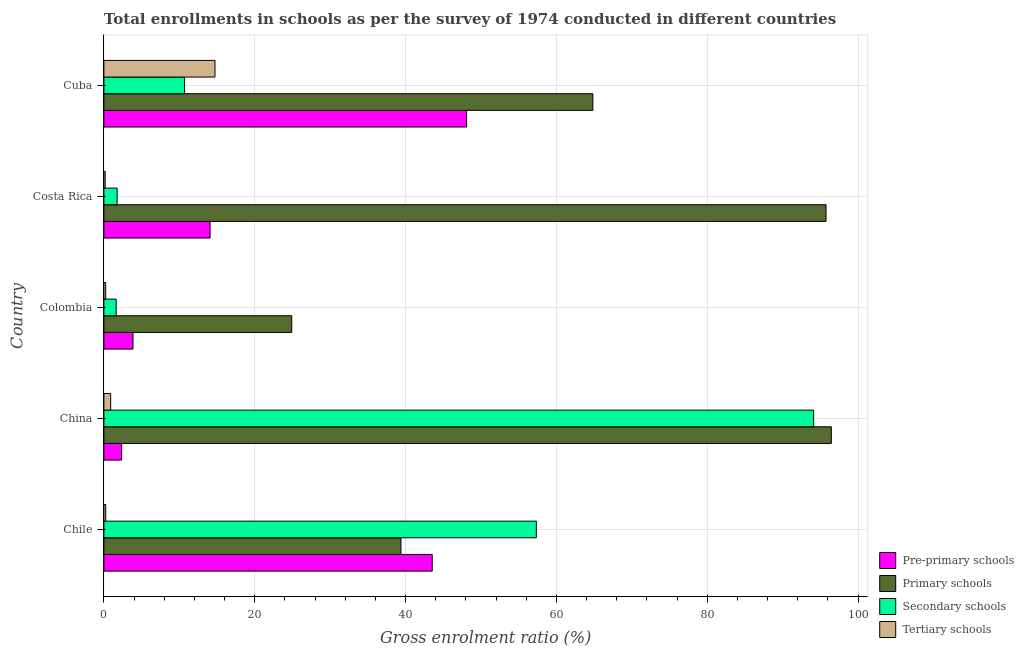Are the number of bars per tick equal to the number of legend labels?
Make the answer very short. Yes. How many bars are there on the 5th tick from the top?
Make the answer very short. 4. What is the gross enrolment ratio in tertiary schools in China?
Your answer should be very brief. 0.9. Across all countries, what is the maximum gross enrolment ratio in primary schools?
Your response must be concise. 96.44. Across all countries, what is the minimum gross enrolment ratio in primary schools?
Your answer should be compact. 24.91. In which country was the gross enrolment ratio in tertiary schools maximum?
Offer a very short reply. Cuba. In which country was the gross enrolment ratio in pre-primary schools minimum?
Give a very brief answer. China. What is the total gross enrolment ratio in primary schools in the graph?
Your response must be concise. 321.3. What is the difference between the gross enrolment ratio in primary schools in China and that in Costa Rica?
Your response must be concise. 0.7. What is the difference between the gross enrolment ratio in primary schools in Costa Rica and the gross enrolment ratio in pre-primary schools in Cuba?
Offer a terse response. 47.65. What is the average gross enrolment ratio in primary schools per country?
Provide a succinct answer. 64.26. What is the difference between the gross enrolment ratio in secondary schools and gross enrolment ratio in primary schools in Cuba?
Offer a terse response. -54.13. In how many countries, is the gross enrolment ratio in tertiary schools greater than 24 %?
Your response must be concise. 0. What is the ratio of the gross enrolment ratio in secondary schools in China to that in Cuba?
Your response must be concise. 8.8. What is the difference between the highest and the second highest gross enrolment ratio in tertiary schools?
Offer a terse response. 13.83. What is the difference between the highest and the lowest gross enrolment ratio in pre-primary schools?
Your answer should be compact. 45.74. Is the sum of the gross enrolment ratio in pre-primary schools in Costa Rica and Cuba greater than the maximum gross enrolment ratio in tertiary schools across all countries?
Provide a short and direct response. Yes. Is it the case that in every country, the sum of the gross enrolment ratio in primary schools and gross enrolment ratio in secondary schools is greater than the sum of gross enrolment ratio in tertiary schools and gross enrolment ratio in pre-primary schools?
Ensure brevity in your answer.  Yes. What does the 4th bar from the top in Colombia represents?
Your response must be concise. Pre-primary schools. What does the 2nd bar from the bottom in Costa Rica represents?
Provide a succinct answer. Primary schools. Is it the case that in every country, the sum of the gross enrolment ratio in pre-primary schools and gross enrolment ratio in primary schools is greater than the gross enrolment ratio in secondary schools?
Your answer should be very brief. Yes. How many bars are there?
Offer a very short reply. 20. Are all the bars in the graph horizontal?
Ensure brevity in your answer.  Yes. How many countries are there in the graph?
Make the answer very short. 5. Are the values on the major ticks of X-axis written in scientific E-notation?
Offer a terse response. No. Does the graph contain any zero values?
Give a very brief answer. No. How many legend labels are there?
Provide a succinct answer. 4. How are the legend labels stacked?
Ensure brevity in your answer.  Vertical. What is the title of the graph?
Your answer should be very brief. Total enrollments in schools as per the survey of 1974 conducted in different countries. What is the label or title of the Y-axis?
Offer a terse response. Country. What is the Gross enrolment ratio (%) of Pre-primary schools in Chile?
Provide a succinct answer. 43.53. What is the Gross enrolment ratio (%) of Primary schools in Chile?
Your answer should be very brief. 39.38. What is the Gross enrolment ratio (%) of Secondary schools in Chile?
Your answer should be compact. 57.33. What is the Gross enrolment ratio (%) of Tertiary schools in Chile?
Keep it short and to the point. 0.24. What is the Gross enrolment ratio (%) in Pre-primary schools in China?
Make the answer very short. 2.35. What is the Gross enrolment ratio (%) in Primary schools in China?
Your answer should be compact. 96.44. What is the Gross enrolment ratio (%) in Secondary schools in China?
Provide a short and direct response. 94.1. What is the Gross enrolment ratio (%) in Tertiary schools in China?
Make the answer very short. 0.9. What is the Gross enrolment ratio (%) in Pre-primary schools in Colombia?
Provide a succinct answer. 3.86. What is the Gross enrolment ratio (%) of Primary schools in Colombia?
Your answer should be compact. 24.91. What is the Gross enrolment ratio (%) in Secondary schools in Colombia?
Your answer should be compact. 1.63. What is the Gross enrolment ratio (%) in Tertiary schools in Colombia?
Give a very brief answer. 0.24. What is the Gross enrolment ratio (%) of Pre-primary schools in Costa Rica?
Offer a very short reply. 14.08. What is the Gross enrolment ratio (%) in Primary schools in Costa Rica?
Offer a very short reply. 95.74. What is the Gross enrolment ratio (%) in Secondary schools in Costa Rica?
Provide a succinct answer. 1.76. What is the Gross enrolment ratio (%) of Tertiary schools in Costa Rica?
Offer a terse response. 0.17. What is the Gross enrolment ratio (%) of Pre-primary schools in Cuba?
Make the answer very short. 48.09. What is the Gross enrolment ratio (%) in Primary schools in Cuba?
Your response must be concise. 64.83. What is the Gross enrolment ratio (%) of Secondary schools in Cuba?
Keep it short and to the point. 10.7. What is the Gross enrolment ratio (%) in Tertiary schools in Cuba?
Offer a very short reply. 14.73. Across all countries, what is the maximum Gross enrolment ratio (%) of Pre-primary schools?
Your answer should be compact. 48.09. Across all countries, what is the maximum Gross enrolment ratio (%) in Primary schools?
Keep it short and to the point. 96.44. Across all countries, what is the maximum Gross enrolment ratio (%) of Secondary schools?
Give a very brief answer. 94.1. Across all countries, what is the maximum Gross enrolment ratio (%) of Tertiary schools?
Give a very brief answer. 14.73. Across all countries, what is the minimum Gross enrolment ratio (%) of Pre-primary schools?
Your response must be concise. 2.35. Across all countries, what is the minimum Gross enrolment ratio (%) in Primary schools?
Make the answer very short. 24.91. Across all countries, what is the minimum Gross enrolment ratio (%) in Secondary schools?
Make the answer very short. 1.63. Across all countries, what is the minimum Gross enrolment ratio (%) in Tertiary schools?
Provide a short and direct response. 0.17. What is the total Gross enrolment ratio (%) in Pre-primary schools in the graph?
Make the answer very short. 111.91. What is the total Gross enrolment ratio (%) in Primary schools in the graph?
Offer a very short reply. 321.3. What is the total Gross enrolment ratio (%) of Secondary schools in the graph?
Ensure brevity in your answer.  165.52. What is the total Gross enrolment ratio (%) of Tertiary schools in the graph?
Make the answer very short. 16.28. What is the difference between the Gross enrolment ratio (%) of Pre-primary schools in Chile and that in China?
Provide a succinct answer. 41.18. What is the difference between the Gross enrolment ratio (%) in Primary schools in Chile and that in China?
Provide a short and direct response. -57.06. What is the difference between the Gross enrolment ratio (%) in Secondary schools in Chile and that in China?
Ensure brevity in your answer.  -36.77. What is the difference between the Gross enrolment ratio (%) in Tertiary schools in Chile and that in China?
Make the answer very short. -0.66. What is the difference between the Gross enrolment ratio (%) of Pre-primary schools in Chile and that in Colombia?
Your response must be concise. 39.67. What is the difference between the Gross enrolment ratio (%) in Primary schools in Chile and that in Colombia?
Make the answer very short. 14.47. What is the difference between the Gross enrolment ratio (%) in Secondary schools in Chile and that in Colombia?
Provide a succinct answer. 55.71. What is the difference between the Gross enrolment ratio (%) of Tertiary schools in Chile and that in Colombia?
Keep it short and to the point. 0. What is the difference between the Gross enrolment ratio (%) of Pre-primary schools in Chile and that in Costa Rica?
Ensure brevity in your answer.  29.45. What is the difference between the Gross enrolment ratio (%) of Primary schools in Chile and that in Costa Rica?
Make the answer very short. -56.36. What is the difference between the Gross enrolment ratio (%) in Secondary schools in Chile and that in Costa Rica?
Offer a terse response. 55.58. What is the difference between the Gross enrolment ratio (%) of Tertiary schools in Chile and that in Costa Rica?
Keep it short and to the point. 0.07. What is the difference between the Gross enrolment ratio (%) of Pre-primary schools in Chile and that in Cuba?
Offer a very short reply. -4.56. What is the difference between the Gross enrolment ratio (%) in Primary schools in Chile and that in Cuba?
Ensure brevity in your answer.  -25.44. What is the difference between the Gross enrolment ratio (%) of Secondary schools in Chile and that in Cuba?
Provide a succinct answer. 46.64. What is the difference between the Gross enrolment ratio (%) of Tertiary schools in Chile and that in Cuba?
Your answer should be very brief. -14.48. What is the difference between the Gross enrolment ratio (%) of Pre-primary schools in China and that in Colombia?
Keep it short and to the point. -1.51. What is the difference between the Gross enrolment ratio (%) of Primary schools in China and that in Colombia?
Ensure brevity in your answer.  71.53. What is the difference between the Gross enrolment ratio (%) of Secondary schools in China and that in Colombia?
Offer a terse response. 92.47. What is the difference between the Gross enrolment ratio (%) in Tertiary schools in China and that in Colombia?
Make the answer very short. 0.66. What is the difference between the Gross enrolment ratio (%) in Pre-primary schools in China and that in Costa Rica?
Make the answer very short. -11.73. What is the difference between the Gross enrolment ratio (%) in Primary schools in China and that in Costa Rica?
Make the answer very short. 0.7. What is the difference between the Gross enrolment ratio (%) of Secondary schools in China and that in Costa Rica?
Your answer should be very brief. 92.34. What is the difference between the Gross enrolment ratio (%) of Tertiary schools in China and that in Costa Rica?
Your answer should be compact. 0.72. What is the difference between the Gross enrolment ratio (%) in Pre-primary schools in China and that in Cuba?
Keep it short and to the point. -45.74. What is the difference between the Gross enrolment ratio (%) in Primary schools in China and that in Cuba?
Your answer should be very brief. 31.62. What is the difference between the Gross enrolment ratio (%) in Secondary schools in China and that in Cuba?
Provide a short and direct response. 83.4. What is the difference between the Gross enrolment ratio (%) in Tertiary schools in China and that in Cuba?
Your response must be concise. -13.83. What is the difference between the Gross enrolment ratio (%) in Pre-primary schools in Colombia and that in Costa Rica?
Your answer should be very brief. -10.22. What is the difference between the Gross enrolment ratio (%) of Primary schools in Colombia and that in Costa Rica?
Provide a succinct answer. -70.84. What is the difference between the Gross enrolment ratio (%) in Secondary schools in Colombia and that in Costa Rica?
Provide a short and direct response. -0.13. What is the difference between the Gross enrolment ratio (%) in Tertiary schools in Colombia and that in Costa Rica?
Ensure brevity in your answer.  0.06. What is the difference between the Gross enrolment ratio (%) in Pre-primary schools in Colombia and that in Cuba?
Ensure brevity in your answer.  -44.23. What is the difference between the Gross enrolment ratio (%) in Primary schools in Colombia and that in Cuba?
Keep it short and to the point. -39.92. What is the difference between the Gross enrolment ratio (%) in Secondary schools in Colombia and that in Cuba?
Your response must be concise. -9.07. What is the difference between the Gross enrolment ratio (%) in Tertiary schools in Colombia and that in Cuba?
Offer a very short reply. -14.49. What is the difference between the Gross enrolment ratio (%) of Pre-primary schools in Costa Rica and that in Cuba?
Your answer should be very brief. -34.01. What is the difference between the Gross enrolment ratio (%) of Primary schools in Costa Rica and that in Cuba?
Make the answer very short. 30.92. What is the difference between the Gross enrolment ratio (%) in Secondary schools in Costa Rica and that in Cuba?
Provide a short and direct response. -8.94. What is the difference between the Gross enrolment ratio (%) in Tertiary schools in Costa Rica and that in Cuba?
Your answer should be compact. -14.55. What is the difference between the Gross enrolment ratio (%) of Pre-primary schools in Chile and the Gross enrolment ratio (%) of Primary schools in China?
Your response must be concise. -52.91. What is the difference between the Gross enrolment ratio (%) of Pre-primary schools in Chile and the Gross enrolment ratio (%) of Secondary schools in China?
Provide a succinct answer. -50.57. What is the difference between the Gross enrolment ratio (%) of Pre-primary schools in Chile and the Gross enrolment ratio (%) of Tertiary schools in China?
Offer a terse response. 42.63. What is the difference between the Gross enrolment ratio (%) of Primary schools in Chile and the Gross enrolment ratio (%) of Secondary schools in China?
Offer a very short reply. -54.72. What is the difference between the Gross enrolment ratio (%) in Primary schools in Chile and the Gross enrolment ratio (%) in Tertiary schools in China?
Ensure brevity in your answer.  38.48. What is the difference between the Gross enrolment ratio (%) in Secondary schools in Chile and the Gross enrolment ratio (%) in Tertiary schools in China?
Offer a terse response. 56.44. What is the difference between the Gross enrolment ratio (%) in Pre-primary schools in Chile and the Gross enrolment ratio (%) in Primary schools in Colombia?
Make the answer very short. 18.62. What is the difference between the Gross enrolment ratio (%) in Pre-primary schools in Chile and the Gross enrolment ratio (%) in Secondary schools in Colombia?
Your answer should be compact. 41.9. What is the difference between the Gross enrolment ratio (%) of Pre-primary schools in Chile and the Gross enrolment ratio (%) of Tertiary schools in Colombia?
Provide a succinct answer. 43.29. What is the difference between the Gross enrolment ratio (%) of Primary schools in Chile and the Gross enrolment ratio (%) of Secondary schools in Colombia?
Offer a very short reply. 37.75. What is the difference between the Gross enrolment ratio (%) in Primary schools in Chile and the Gross enrolment ratio (%) in Tertiary schools in Colombia?
Make the answer very short. 39.14. What is the difference between the Gross enrolment ratio (%) in Secondary schools in Chile and the Gross enrolment ratio (%) in Tertiary schools in Colombia?
Provide a succinct answer. 57.09. What is the difference between the Gross enrolment ratio (%) in Pre-primary schools in Chile and the Gross enrolment ratio (%) in Primary schools in Costa Rica?
Your answer should be compact. -52.21. What is the difference between the Gross enrolment ratio (%) of Pre-primary schools in Chile and the Gross enrolment ratio (%) of Secondary schools in Costa Rica?
Provide a succinct answer. 41.78. What is the difference between the Gross enrolment ratio (%) of Pre-primary schools in Chile and the Gross enrolment ratio (%) of Tertiary schools in Costa Rica?
Ensure brevity in your answer.  43.36. What is the difference between the Gross enrolment ratio (%) in Primary schools in Chile and the Gross enrolment ratio (%) in Secondary schools in Costa Rica?
Your answer should be compact. 37.63. What is the difference between the Gross enrolment ratio (%) of Primary schools in Chile and the Gross enrolment ratio (%) of Tertiary schools in Costa Rica?
Your response must be concise. 39.21. What is the difference between the Gross enrolment ratio (%) in Secondary schools in Chile and the Gross enrolment ratio (%) in Tertiary schools in Costa Rica?
Offer a terse response. 57.16. What is the difference between the Gross enrolment ratio (%) in Pre-primary schools in Chile and the Gross enrolment ratio (%) in Primary schools in Cuba?
Give a very brief answer. -21.3. What is the difference between the Gross enrolment ratio (%) in Pre-primary schools in Chile and the Gross enrolment ratio (%) in Secondary schools in Cuba?
Your answer should be compact. 32.83. What is the difference between the Gross enrolment ratio (%) in Pre-primary schools in Chile and the Gross enrolment ratio (%) in Tertiary schools in Cuba?
Make the answer very short. 28.8. What is the difference between the Gross enrolment ratio (%) in Primary schools in Chile and the Gross enrolment ratio (%) in Secondary schools in Cuba?
Your answer should be very brief. 28.68. What is the difference between the Gross enrolment ratio (%) in Primary schools in Chile and the Gross enrolment ratio (%) in Tertiary schools in Cuba?
Provide a short and direct response. 24.65. What is the difference between the Gross enrolment ratio (%) in Secondary schools in Chile and the Gross enrolment ratio (%) in Tertiary schools in Cuba?
Your answer should be compact. 42.61. What is the difference between the Gross enrolment ratio (%) in Pre-primary schools in China and the Gross enrolment ratio (%) in Primary schools in Colombia?
Give a very brief answer. -22.56. What is the difference between the Gross enrolment ratio (%) of Pre-primary schools in China and the Gross enrolment ratio (%) of Secondary schools in Colombia?
Offer a very short reply. 0.72. What is the difference between the Gross enrolment ratio (%) in Pre-primary schools in China and the Gross enrolment ratio (%) in Tertiary schools in Colombia?
Offer a very short reply. 2.11. What is the difference between the Gross enrolment ratio (%) of Primary schools in China and the Gross enrolment ratio (%) of Secondary schools in Colombia?
Your answer should be compact. 94.81. What is the difference between the Gross enrolment ratio (%) of Primary schools in China and the Gross enrolment ratio (%) of Tertiary schools in Colombia?
Your response must be concise. 96.2. What is the difference between the Gross enrolment ratio (%) in Secondary schools in China and the Gross enrolment ratio (%) in Tertiary schools in Colombia?
Make the answer very short. 93.86. What is the difference between the Gross enrolment ratio (%) in Pre-primary schools in China and the Gross enrolment ratio (%) in Primary schools in Costa Rica?
Provide a succinct answer. -93.39. What is the difference between the Gross enrolment ratio (%) in Pre-primary schools in China and the Gross enrolment ratio (%) in Secondary schools in Costa Rica?
Offer a very short reply. 0.6. What is the difference between the Gross enrolment ratio (%) in Pre-primary schools in China and the Gross enrolment ratio (%) in Tertiary schools in Costa Rica?
Your answer should be very brief. 2.18. What is the difference between the Gross enrolment ratio (%) in Primary schools in China and the Gross enrolment ratio (%) in Secondary schools in Costa Rica?
Your answer should be compact. 94.69. What is the difference between the Gross enrolment ratio (%) of Primary schools in China and the Gross enrolment ratio (%) of Tertiary schools in Costa Rica?
Your answer should be very brief. 96.27. What is the difference between the Gross enrolment ratio (%) in Secondary schools in China and the Gross enrolment ratio (%) in Tertiary schools in Costa Rica?
Offer a very short reply. 93.92. What is the difference between the Gross enrolment ratio (%) of Pre-primary schools in China and the Gross enrolment ratio (%) of Primary schools in Cuba?
Offer a very short reply. -62.48. What is the difference between the Gross enrolment ratio (%) of Pre-primary schools in China and the Gross enrolment ratio (%) of Secondary schools in Cuba?
Give a very brief answer. -8.35. What is the difference between the Gross enrolment ratio (%) in Pre-primary schools in China and the Gross enrolment ratio (%) in Tertiary schools in Cuba?
Keep it short and to the point. -12.38. What is the difference between the Gross enrolment ratio (%) of Primary schools in China and the Gross enrolment ratio (%) of Secondary schools in Cuba?
Offer a terse response. 85.75. What is the difference between the Gross enrolment ratio (%) of Primary schools in China and the Gross enrolment ratio (%) of Tertiary schools in Cuba?
Provide a succinct answer. 81.72. What is the difference between the Gross enrolment ratio (%) in Secondary schools in China and the Gross enrolment ratio (%) in Tertiary schools in Cuba?
Your answer should be compact. 79.37. What is the difference between the Gross enrolment ratio (%) in Pre-primary schools in Colombia and the Gross enrolment ratio (%) in Primary schools in Costa Rica?
Provide a short and direct response. -91.89. What is the difference between the Gross enrolment ratio (%) in Pre-primary schools in Colombia and the Gross enrolment ratio (%) in Secondary schools in Costa Rica?
Ensure brevity in your answer.  2.1. What is the difference between the Gross enrolment ratio (%) of Pre-primary schools in Colombia and the Gross enrolment ratio (%) of Tertiary schools in Costa Rica?
Your answer should be compact. 3.68. What is the difference between the Gross enrolment ratio (%) of Primary schools in Colombia and the Gross enrolment ratio (%) of Secondary schools in Costa Rica?
Ensure brevity in your answer.  23.15. What is the difference between the Gross enrolment ratio (%) of Primary schools in Colombia and the Gross enrolment ratio (%) of Tertiary schools in Costa Rica?
Provide a succinct answer. 24.73. What is the difference between the Gross enrolment ratio (%) of Secondary schools in Colombia and the Gross enrolment ratio (%) of Tertiary schools in Costa Rica?
Give a very brief answer. 1.45. What is the difference between the Gross enrolment ratio (%) in Pre-primary schools in Colombia and the Gross enrolment ratio (%) in Primary schools in Cuba?
Ensure brevity in your answer.  -60.97. What is the difference between the Gross enrolment ratio (%) of Pre-primary schools in Colombia and the Gross enrolment ratio (%) of Secondary schools in Cuba?
Keep it short and to the point. -6.84. What is the difference between the Gross enrolment ratio (%) of Pre-primary schools in Colombia and the Gross enrolment ratio (%) of Tertiary schools in Cuba?
Offer a very short reply. -10.87. What is the difference between the Gross enrolment ratio (%) of Primary schools in Colombia and the Gross enrolment ratio (%) of Secondary schools in Cuba?
Offer a terse response. 14.21. What is the difference between the Gross enrolment ratio (%) of Primary schools in Colombia and the Gross enrolment ratio (%) of Tertiary schools in Cuba?
Offer a very short reply. 10.18. What is the difference between the Gross enrolment ratio (%) in Secondary schools in Colombia and the Gross enrolment ratio (%) in Tertiary schools in Cuba?
Offer a terse response. -13.1. What is the difference between the Gross enrolment ratio (%) in Pre-primary schools in Costa Rica and the Gross enrolment ratio (%) in Primary schools in Cuba?
Your response must be concise. -50.75. What is the difference between the Gross enrolment ratio (%) of Pre-primary schools in Costa Rica and the Gross enrolment ratio (%) of Secondary schools in Cuba?
Provide a succinct answer. 3.38. What is the difference between the Gross enrolment ratio (%) in Pre-primary schools in Costa Rica and the Gross enrolment ratio (%) in Tertiary schools in Cuba?
Offer a very short reply. -0.65. What is the difference between the Gross enrolment ratio (%) in Primary schools in Costa Rica and the Gross enrolment ratio (%) in Secondary schools in Cuba?
Ensure brevity in your answer.  85.05. What is the difference between the Gross enrolment ratio (%) of Primary schools in Costa Rica and the Gross enrolment ratio (%) of Tertiary schools in Cuba?
Your response must be concise. 81.02. What is the difference between the Gross enrolment ratio (%) in Secondary schools in Costa Rica and the Gross enrolment ratio (%) in Tertiary schools in Cuba?
Offer a very short reply. -12.97. What is the average Gross enrolment ratio (%) in Pre-primary schools per country?
Your response must be concise. 22.38. What is the average Gross enrolment ratio (%) of Primary schools per country?
Provide a short and direct response. 64.26. What is the average Gross enrolment ratio (%) of Secondary schools per country?
Give a very brief answer. 33.1. What is the average Gross enrolment ratio (%) of Tertiary schools per country?
Provide a succinct answer. 3.26. What is the difference between the Gross enrolment ratio (%) of Pre-primary schools and Gross enrolment ratio (%) of Primary schools in Chile?
Give a very brief answer. 4.15. What is the difference between the Gross enrolment ratio (%) in Pre-primary schools and Gross enrolment ratio (%) in Secondary schools in Chile?
Ensure brevity in your answer.  -13.8. What is the difference between the Gross enrolment ratio (%) in Pre-primary schools and Gross enrolment ratio (%) in Tertiary schools in Chile?
Give a very brief answer. 43.29. What is the difference between the Gross enrolment ratio (%) in Primary schools and Gross enrolment ratio (%) in Secondary schools in Chile?
Give a very brief answer. -17.95. What is the difference between the Gross enrolment ratio (%) of Primary schools and Gross enrolment ratio (%) of Tertiary schools in Chile?
Your answer should be compact. 39.14. What is the difference between the Gross enrolment ratio (%) in Secondary schools and Gross enrolment ratio (%) in Tertiary schools in Chile?
Your response must be concise. 57.09. What is the difference between the Gross enrolment ratio (%) in Pre-primary schools and Gross enrolment ratio (%) in Primary schools in China?
Offer a very short reply. -94.09. What is the difference between the Gross enrolment ratio (%) in Pre-primary schools and Gross enrolment ratio (%) in Secondary schools in China?
Your answer should be very brief. -91.75. What is the difference between the Gross enrolment ratio (%) of Pre-primary schools and Gross enrolment ratio (%) of Tertiary schools in China?
Make the answer very short. 1.45. What is the difference between the Gross enrolment ratio (%) of Primary schools and Gross enrolment ratio (%) of Secondary schools in China?
Your answer should be very brief. 2.34. What is the difference between the Gross enrolment ratio (%) in Primary schools and Gross enrolment ratio (%) in Tertiary schools in China?
Your answer should be compact. 95.54. What is the difference between the Gross enrolment ratio (%) in Secondary schools and Gross enrolment ratio (%) in Tertiary schools in China?
Give a very brief answer. 93.2. What is the difference between the Gross enrolment ratio (%) in Pre-primary schools and Gross enrolment ratio (%) in Primary schools in Colombia?
Ensure brevity in your answer.  -21.05. What is the difference between the Gross enrolment ratio (%) in Pre-primary schools and Gross enrolment ratio (%) in Secondary schools in Colombia?
Give a very brief answer. 2.23. What is the difference between the Gross enrolment ratio (%) in Pre-primary schools and Gross enrolment ratio (%) in Tertiary schools in Colombia?
Keep it short and to the point. 3.62. What is the difference between the Gross enrolment ratio (%) of Primary schools and Gross enrolment ratio (%) of Secondary schools in Colombia?
Provide a succinct answer. 23.28. What is the difference between the Gross enrolment ratio (%) in Primary schools and Gross enrolment ratio (%) in Tertiary schools in Colombia?
Make the answer very short. 24.67. What is the difference between the Gross enrolment ratio (%) in Secondary schools and Gross enrolment ratio (%) in Tertiary schools in Colombia?
Give a very brief answer. 1.39. What is the difference between the Gross enrolment ratio (%) in Pre-primary schools and Gross enrolment ratio (%) in Primary schools in Costa Rica?
Offer a terse response. -81.67. What is the difference between the Gross enrolment ratio (%) of Pre-primary schools and Gross enrolment ratio (%) of Secondary schools in Costa Rica?
Make the answer very short. 12.32. What is the difference between the Gross enrolment ratio (%) of Pre-primary schools and Gross enrolment ratio (%) of Tertiary schools in Costa Rica?
Make the answer very short. 13.9. What is the difference between the Gross enrolment ratio (%) of Primary schools and Gross enrolment ratio (%) of Secondary schools in Costa Rica?
Your response must be concise. 93.99. What is the difference between the Gross enrolment ratio (%) in Primary schools and Gross enrolment ratio (%) in Tertiary schools in Costa Rica?
Your answer should be very brief. 95.57. What is the difference between the Gross enrolment ratio (%) in Secondary schools and Gross enrolment ratio (%) in Tertiary schools in Costa Rica?
Keep it short and to the point. 1.58. What is the difference between the Gross enrolment ratio (%) of Pre-primary schools and Gross enrolment ratio (%) of Primary schools in Cuba?
Provide a succinct answer. -16.74. What is the difference between the Gross enrolment ratio (%) in Pre-primary schools and Gross enrolment ratio (%) in Secondary schools in Cuba?
Your response must be concise. 37.39. What is the difference between the Gross enrolment ratio (%) in Pre-primary schools and Gross enrolment ratio (%) in Tertiary schools in Cuba?
Your response must be concise. 33.36. What is the difference between the Gross enrolment ratio (%) in Primary schools and Gross enrolment ratio (%) in Secondary schools in Cuba?
Your answer should be very brief. 54.13. What is the difference between the Gross enrolment ratio (%) of Primary schools and Gross enrolment ratio (%) of Tertiary schools in Cuba?
Make the answer very short. 50.1. What is the difference between the Gross enrolment ratio (%) of Secondary schools and Gross enrolment ratio (%) of Tertiary schools in Cuba?
Your answer should be very brief. -4.03. What is the ratio of the Gross enrolment ratio (%) of Pre-primary schools in Chile to that in China?
Make the answer very short. 18.51. What is the ratio of the Gross enrolment ratio (%) in Primary schools in Chile to that in China?
Keep it short and to the point. 0.41. What is the ratio of the Gross enrolment ratio (%) in Secondary schools in Chile to that in China?
Make the answer very short. 0.61. What is the ratio of the Gross enrolment ratio (%) of Tertiary schools in Chile to that in China?
Ensure brevity in your answer.  0.27. What is the ratio of the Gross enrolment ratio (%) in Pre-primary schools in Chile to that in Colombia?
Make the answer very short. 11.28. What is the ratio of the Gross enrolment ratio (%) of Primary schools in Chile to that in Colombia?
Provide a succinct answer. 1.58. What is the ratio of the Gross enrolment ratio (%) in Secondary schools in Chile to that in Colombia?
Offer a very short reply. 35.21. What is the ratio of the Gross enrolment ratio (%) of Tertiary schools in Chile to that in Colombia?
Offer a very short reply. 1.02. What is the ratio of the Gross enrolment ratio (%) in Pre-primary schools in Chile to that in Costa Rica?
Keep it short and to the point. 3.09. What is the ratio of the Gross enrolment ratio (%) in Primary schools in Chile to that in Costa Rica?
Ensure brevity in your answer.  0.41. What is the ratio of the Gross enrolment ratio (%) of Secondary schools in Chile to that in Costa Rica?
Give a very brief answer. 32.65. What is the ratio of the Gross enrolment ratio (%) in Tertiary schools in Chile to that in Costa Rica?
Offer a very short reply. 1.39. What is the ratio of the Gross enrolment ratio (%) in Pre-primary schools in Chile to that in Cuba?
Offer a terse response. 0.91. What is the ratio of the Gross enrolment ratio (%) of Primary schools in Chile to that in Cuba?
Give a very brief answer. 0.61. What is the ratio of the Gross enrolment ratio (%) in Secondary schools in Chile to that in Cuba?
Offer a very short reply. 5.36. What is the ratio of the Gross enrolment ratio (%) of Tertiary schools in Chile to that in Cuba?
Provide a short and direct response. 0.02. What is the ratio of the Gross enrolment ratio (%) in Pre-primary schools in China to that in Colombia?
Your answer should be compact. 0.61. What is the ratio of the Gross enrolment ratio (%) of Primary schools in China to that in Colombia?
Offer a terse response. 3.87. What is the ratio of the Gross enrolment ratio (%) of Secondary schools in China to that in Colombia?
Ensure brevity in your answer.  57.8. What is the ratio of the Gross enrolment ratio (%) in Tertiary schools in China to that in Colombia?
Provide a succinct answer. 3.75. What is the ratio of the Gross enrolment ratio (%) in Pre-primary schools in China to that in Costa Rica?
Your answer should be compact. 0.17. What is the ratio of the Gross enrolment ratio (%) of Primary schools in China to that in Costa Rica?
Give a very brief answer. 1.01. What is the ratio of the Gross enrolment ratio (%) in Secondary schools in China to that in Costa Rica?
Ensure brevity in your answer.  53.59. What is the ratio of the Gross enrolment ratio (%) in Tertiary schools in China to that in Costa Rica?
Ensure brevity in your answer.  5.15. What is the ratio of the Gross enrolment ratio (%) in Pre-primary schools in China to that in Cuba?
Provide a succinct answer. 0.05. What is the ratio of the Gross enrolment ratio (%) of Primary schools in China to that in Cuba?
Offer a very short reply. 1.49. What is the ratio of the Gross enrolment ratio (%) in Secondary schools in China to that in Cuba?
Your answer should be compact. 8.8. What is the ratio of the Gross enrolment ratio (%) of Tertiary schools in China to that in Cuba?
Offer a very short reply. 0.06. What is the ratio of the Gross enrolment ratio (%) in Pre-primary schools in Colombia to that in Costa Rica?
Ensure brevity in your answer.  0.27. What is the ratio of the Gross enrolment ratio (%) in Primary schools in Colombia to that in Costa Rica?
Give a very brief answer. 0.26. What is the ratio of the Gross enrolment ratio (%) in Secondary schools in Colombia to that in Costa Rica?
Your answer should be very brief. 0.93. What is the ratio of the Gross enrolment ratio (%) in Tertiary schools in Colombia to that in Costa Rica?
Keep it short and to the point. 1.37. What is the ratio of the Gross enrolment ratio (%) of Pre-primary schools in Colombia to that in Cuba?
Provide a short and direct response. 0.08. What is the ratio of the Gross enrolment ratio (%) of Primary schools in Colombia to that in Cuba?
Make the answer very short. 0.38. What is the ratio of the Gross enrolment ratio (%) of Secondary schools in Colombia to that in Cuba?
Offer a very short reply. 0.15. What is the ratio of the Gross enrolment ratio (%) in Tertiary schools in Colombia to that in Cuba?
Provide a short and direct response. 0.02. What is the ratio of the Gross enrolment ratio (%) of Pre-primary schools in Costa Rica to that in Cuba?
Offer a very short reply. 0.29. What is the ratio of the Gross enrolment ratio (%) in Primary schools in Costa Rica to that in Cuba?
Ensure brevity in your answer.  1.48. What is the ratio of the Gross enrolment ratio (%) of Secondary schools in Costa Rica to that in Cuba?
Give a very brief answer. 0.16. What is the ratio of the Gross enrolment ratio (%) of Tertiary schools in Costa Rica to that in Cuba?
Your answer should be very brief. 0.01. What is the difference between the highest and the second highest Gross enrolment ratio (%) in Pre-primary schools?
Ensure brevity in your answer.  4.56. What is the difference between the highest and the second highest Gross enrolment ratio (%) in Primary schools?
Keep it short and to the point. 0.7. What is the difference between the highest and the second highest Gross enrolment ratio (%) of Secondary schools?
Your answer should be very brief. 36.77. What is the difference between the highest and the second highest Gross enrolment ratio (%) in Tertiary schools?
Your response must be concise. 13.83. What is the difference between the highest and the lowest Gross enrolment ratio (%) of Pre-primary schools?
Make the answer very short. 45.74. What is the difference between the highest and the lowest Gross enrolment ratio (%) of Primary schools?
Give a very brief answer. 71.53. What is the difference between the highest and the lowest Gross enrolment ratio (%) in Secondary schools?
Keep it short and to the point. 92.47. What is the difference between the highest and the lowest Gross enrolment ratio (%) in Tertiary schools?
Offer a terse response. 14.55. 